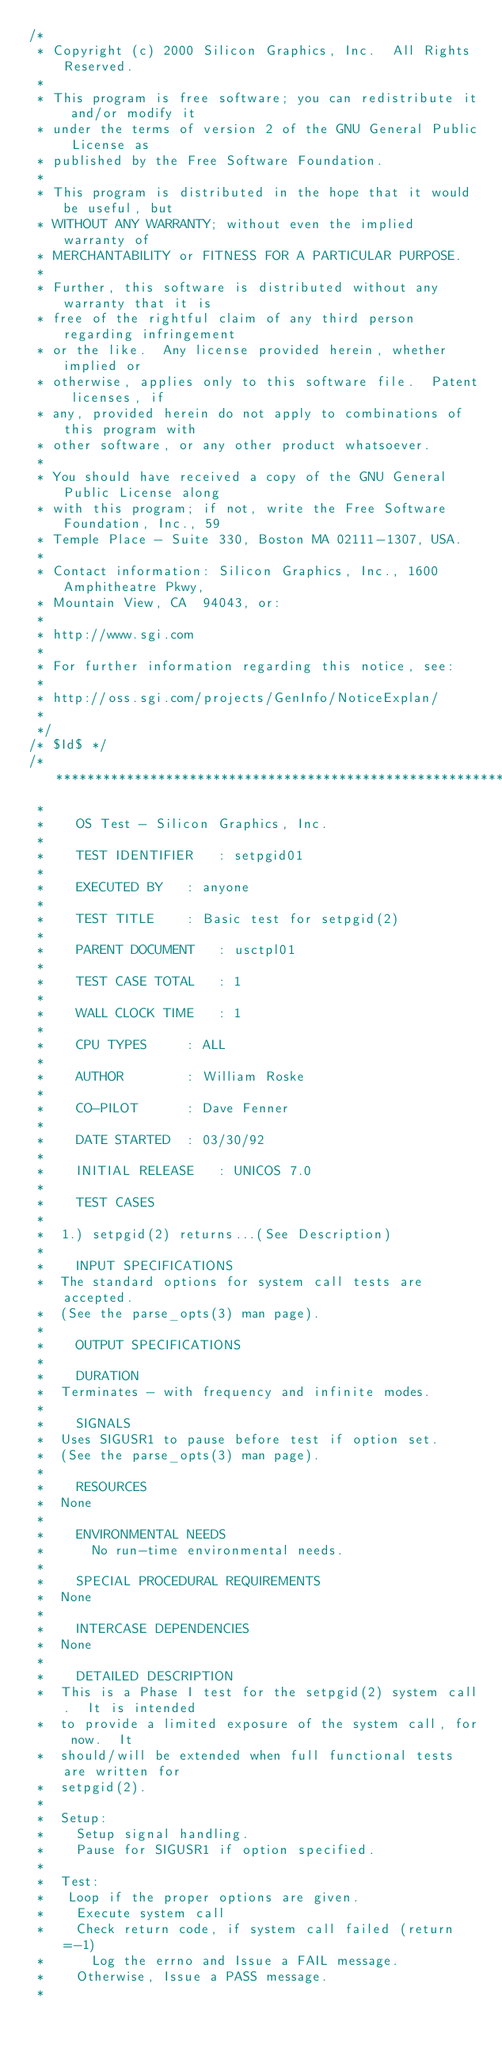Convert code to text. <code><loc_0><loc_0><loc_500><loc_500><_C_>/*
 * Copyright (c) 2000 Silicon Graphics, Inc.  All Rights Reserved.
 *
 * This program is free software; you can redistribute it and/or modify it
 * under the terms of version 2 of the GNU General Public License as
 * published by the Free Software Foundation.
 *
 * This program is distributed in the hope that it would be useful, but
 * WITHOUT ANY WARRANTY; without even the implied warranty of
 * MERCHANTABILITY or FITNESS FOR A PARTICULAR PURPOSE.
 *
 * Further, this software is distributed without any warranty that it is
 * free of the rightful claim of any third person regarding infringement
 * or the like.  Any license provided herein, whether implied or
 * otherwise, applies only to this software file.  Patent licenses, if
 * any, provided herein do not apply to combinations of this program with
 * other software, or any other product whatsoever.
 *
 * You should have received a copy of the GNU General Public License along
 * with this program; if not, write the Free Software Foundation, Inc., 59
 * Temple Place - Suite 330, Boston MA 02111-1307, USA.
 *
 * Contact information: Silicon Graphics, Inc., 1600 Amphitheatre Pkwy,
 * Mountain View, CA  94043, or:
 *
 * http://www.sgi.com
 *
 * For further information regarding this notice, see:
 *
 * http://oss.sgi.com/projects/GenInfo/NoticeExplan/
 *
 */
/* $Id$ */
/**********************************************************
 * 
 *    OS Test - Silicon Graphics, Inc.
 * 
 *    TEST IDENTIFIER	: setpgid01
 * 
 *    EXECUTED BY	: anyone
 * 
 *    TEST TITLE	: Basic test for setpgid(2) 
 * 
 *    PARENT DOCUMENT	: usctpl01
 * 
 *    TEST CASE TOTAL	: 1
 * 
 *    WALL CLOCK TIME	: 1
 * 
 *    CPU TYPES		: ALL
 * 
 *    AUTHOR		: William Roske
 * 
 *    CO-PILOT		: Dave Fenner
 * 
 *    DATE STARTED	: 03/30/92
 * 
 *    INITIAL RELEASE	: UNICOS 7.0
 * 
 *    TEST CASES
 * 
 * 	1.) setpgid(2) returns...(See Description)
 *	
 *    INPUT SPECIFICATIONS
 * 	The standard options for system call tests are accepted.
 *	(See the parse_opts(3) man page).
 * 
 *    OUTPUT SPECIFICATIONS
 * 	
 *    DURATION
 * 	Terminates - with frequency and infinite modes.
 * 
 *    SIGNALS
 * 	Uses SIGUSR1 to pause before test if option set.
 * 	(See the parse_opts(3) man page).
 *
 *    RESOURCES
 * 	None
 * 
 *    ENVIRONMENTAL NEEDS
 *      No run-time environmental needs.
 * 
 *    SPECIAL PROCEDURAL REQUIREMENTS
 * 	None
 * 
 *    INTERCASE DEPENDENCIES
 * 	None
 * 
 *    DETAILED DESCRIPTION
 *	This is a Phase I test for the setpgid(2) system call.  It is intended
 *	to provide a limited exposure of the system call, for now.  It
 *	should/will be extended when full functional tests are written for
 *	setpgid(2).
 * 
 * 	Setup:
 * 	  Setup signal handling.
 *	  Pause for SIGUSR1 if option specified.
 * 
 * 	Test:
 *	 Loop if the proper options are given.
 * 	  Execute system call
 *	  Check return code, if system call failed (return=-1)
 *		Log the errno and Issue a FAIL message.
 *	  Otherwise, Issue a PASS message.
 * </code> 